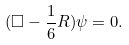Convert formula to latex. <formula><loc_0><loc_0><loc_500><loc_500>( \Box - \frac { 1 } { 6 } R ) \psi = 0 .</formula> 